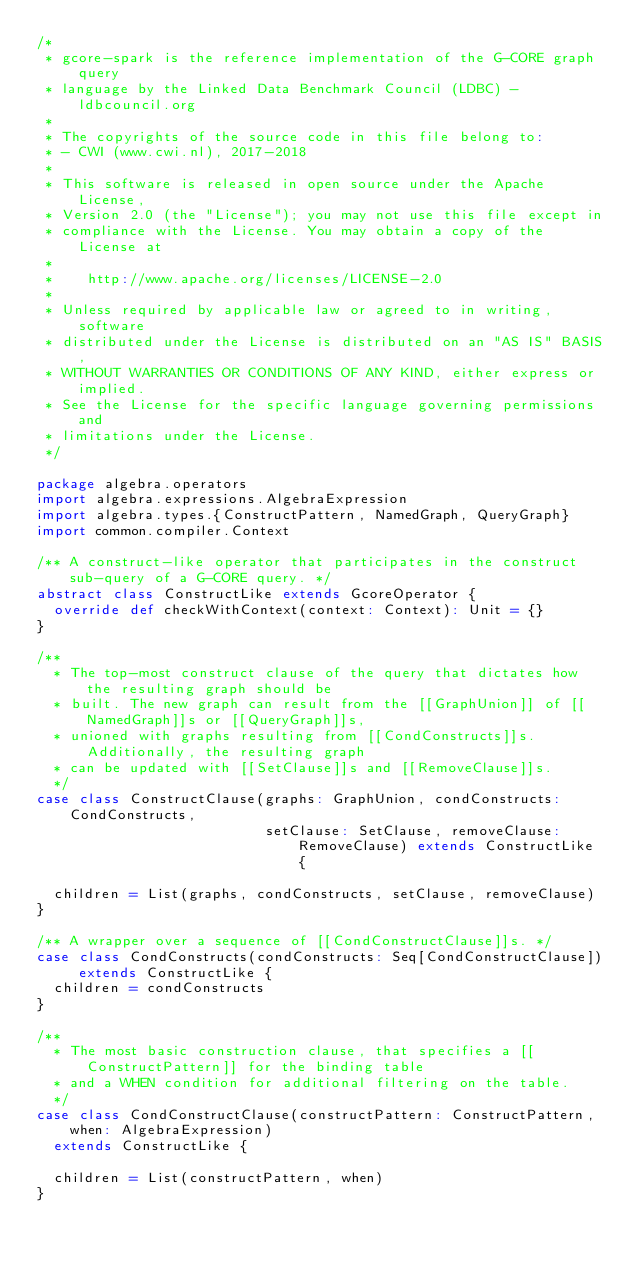<code> <loc_0><loc_0><loc_500><loc_500><_Scala_>/*
 * gcore-spark is the reference implementation of the G-CORE graph query
 * language by the Linked Data Benchmark Council (LDBC) - ldbcouncil.org
 *
 * The copyrights of the source code in this file belong to:
 * - CWI (www.cwi.nl), 2017-2018
 *
 * This software is released in open source under the Apache License, 
 * Version 2.0 (the "License"); you may not use this file except in 
 * compliance with the License. You may obtain a copy of the License at
 *
 *    http://www.apache.org/licenses/LICENSE-2.0
 *
 * Unless required by applicable law or agreed to in writing, software
 * distributed under the License is distributed on an "AS IS" BASIS,
 * WITHOUT WARRANTIES OR CONDITIONS OF ANY KIND, either express or implied.
 * See the License for the specific language governing permissions and
 * limitations under the License.
 */

package algebra.operators
import algebra.expressions.AlgebraExpression
import algebra.types.{ConstructPattern, NamedGraph, QueryGraph}
import common.compiler.Context

/** A construct-like operator that participates in the construct sub-query of a G-CORE query. */
abstract class ConstructLike extends GcoreOperator {
  override def checkWithContext(context: Context): Unit = {}
}

/**
  * The top-most construct clause of the query that dictates how the resulting graph should be
  * built. The new graph can result from the [[GraphUnion]] of [[NamedGraph]]s or [[QueryGraph]]s,
  * unioned with graphs resulting from [[CondConstructs]]s. Additionally, the resulting graph
  * can be updated with [[SetClause]]s and [[RemoveClause]]s.
  */
case class ConstructClause(graphs: GraphUnion, condConstructs: CondConstructs,
                           setClause: SetClause, removeClause: RemoveClause) extends ConstructLike {

  children = List(graphs, condConstructs, setClause, removeClause)
}

/** A wrapper over a sequence of [[CondConstructClause]]s. */
case class CondConstructs(condConstructs: Seq[CondConstructClause]) extends ConstructLike {
  children = condConstructs
}

/**
  * The most basic construction clause, that specifies a [[ConstructPattern]] for the binding table
  * and a WHEN condition for additional filtering on the table.
  */
case class CondConstructClause(constructPattern: ConstructPattern, when: AlgebraExpression)
  extends ConstructLike {

  children = List(constructPattern, when)
}
</code> 